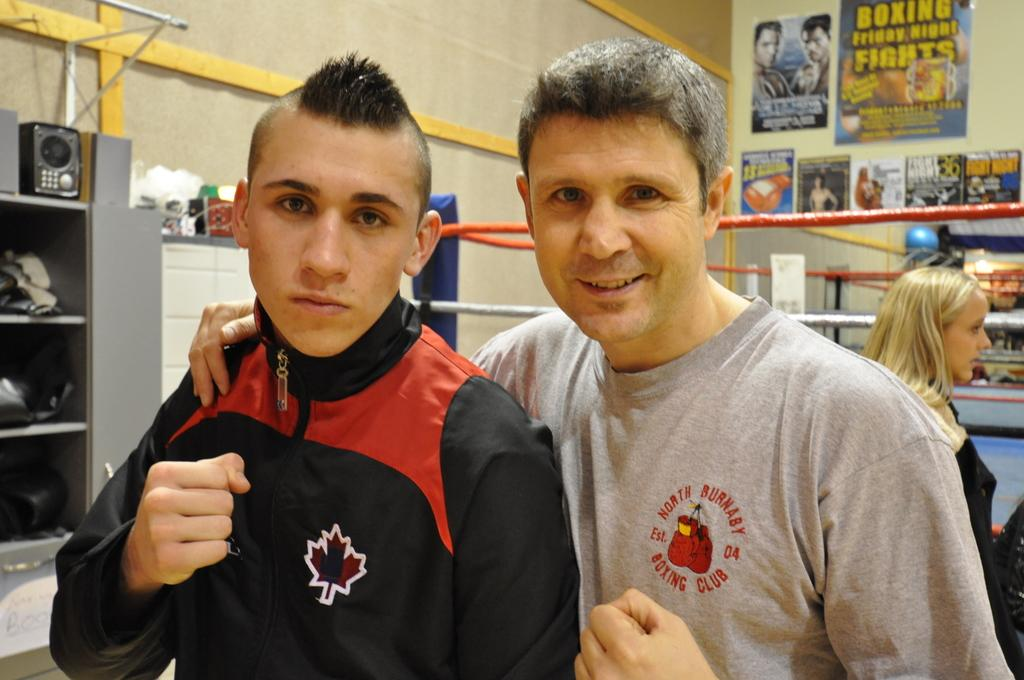<image>
Describe the image concisely. Two guys posing, one wearing a Boxing Club shirt. 